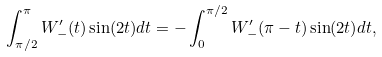<formula> <loc_0><loc_0><loc_500><loc_500>\int _ { \pi / 2 } ^ { \pi } W _ { - } ^ { \prime } ( t ) \sin ( 2 t ) d t = - \int _ { 0 } ^ { \pi / 2 } W _ { - } ^ { \prime } ( \pi - t ) \sin ( 2 t ) d t ,</formula> 